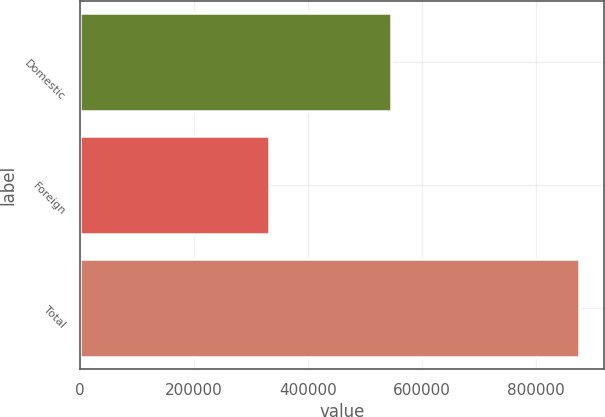Convert chart. <chart><loc_0><loc_0><loc_500><loc_500><bar_chart><fcel>Domestic<fcel>Foreign<fcel>Total<nl><fcel>544900<fcel>330915<fcel>875815<nl></chart> 